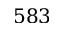Convert formula to latex. <formula><loc_0><loc_0><loc_500><loc_500>5 8 3</formula> 